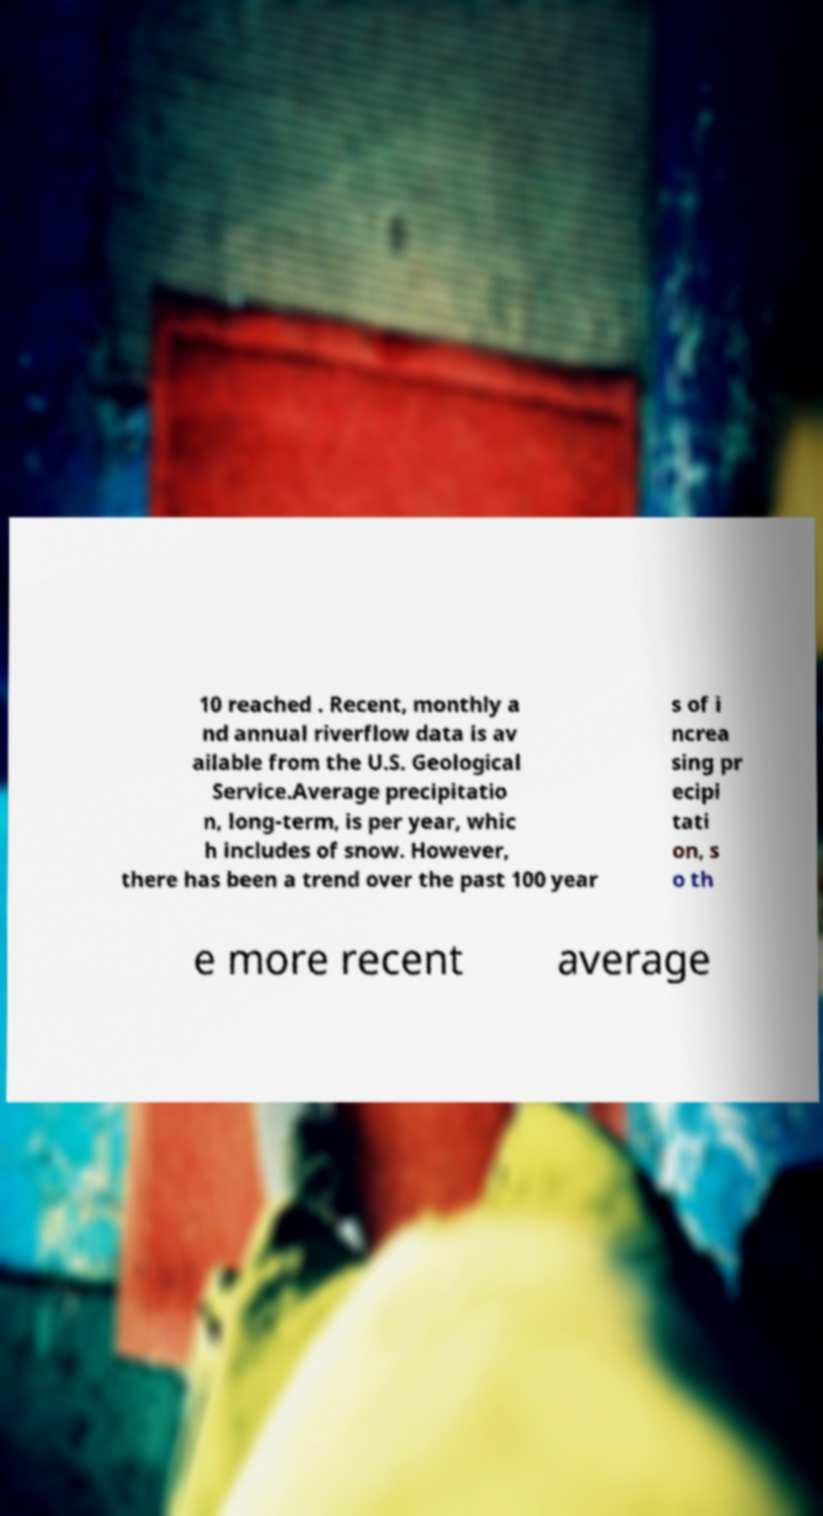Can you accurately transcribe the text from the provided image for me? 10 reached . Recent, monthly a nd annual riverflow data is av ailable from the U.S. Geological Service.Average precipitatio n, long-term, is per year, whic h includes of snow. However, there has been a trend over the past 100 year s of i ncrea sing pr ecipi tati on, s o th e more recent average 